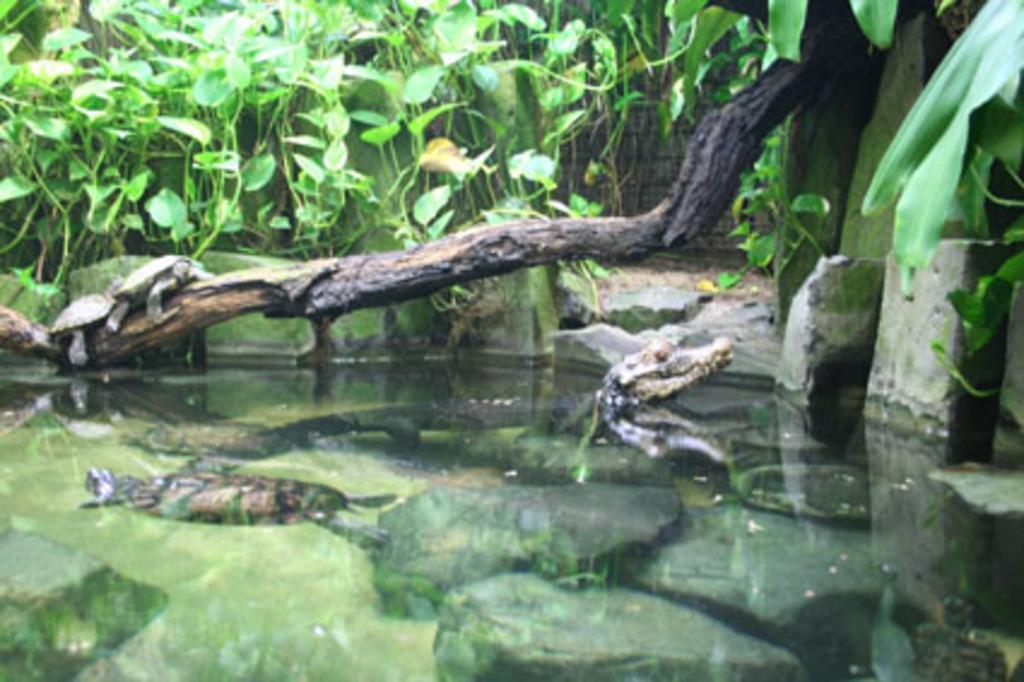Describe this image in one or two sentences. In this image we can see water, rocks, water animals, branch, two tortoise and leaves. 